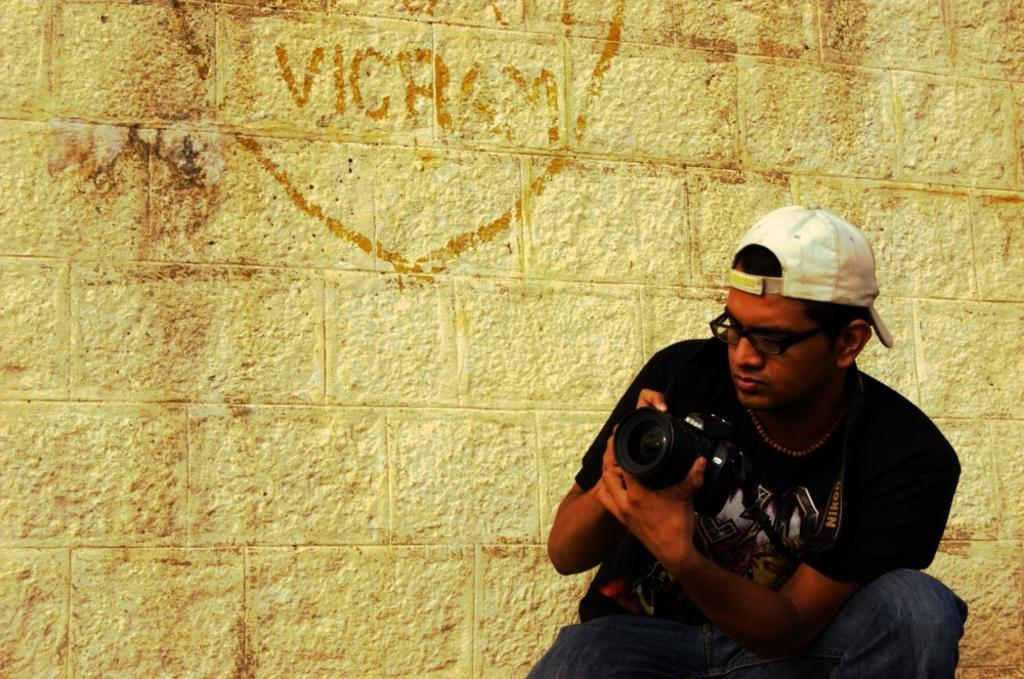What is the main subject of the image? There is a man in the image. What is the man wearing on his upper body? The man is wearing a black t-shirt. What is the man wearing on his head? The man is wearing a white cap. What is the man holding in his hands? The man is holding a camera in his hands. What can be seen in the background of the image? There is a wall in the background of the image. What is written on the wall in the background? Something is written on the wall in the background. What type of canvas is the man painting on in the image? There is no canvas present in the image, nor is the man painting. 